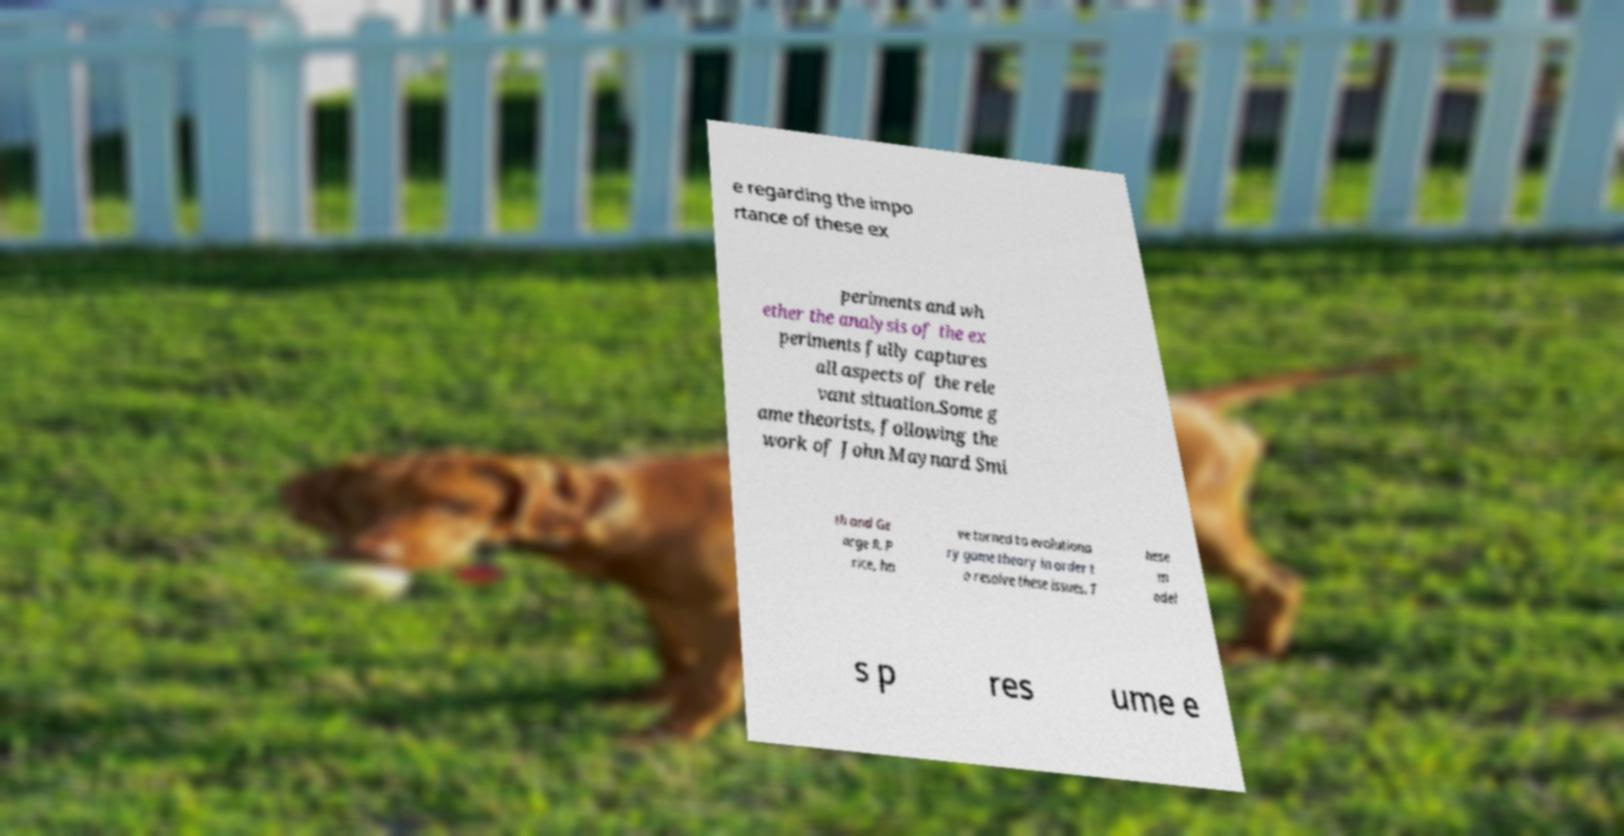Can you read and provide the text displayed in the image?This photo seems to have some interesting text. Can you extract and type it out for me? e regarding the impo rtance of these ex periments and wh ether the analysis of the ex periments fully captures all aspects of the rele vant situation.Some g ame theorists, following the work of John Maynard Smi th and Ge orge R. P rice, ha ve turned to evolutiona ry game theory in order t o resolve these issues. T hese m odel s p res ume e 